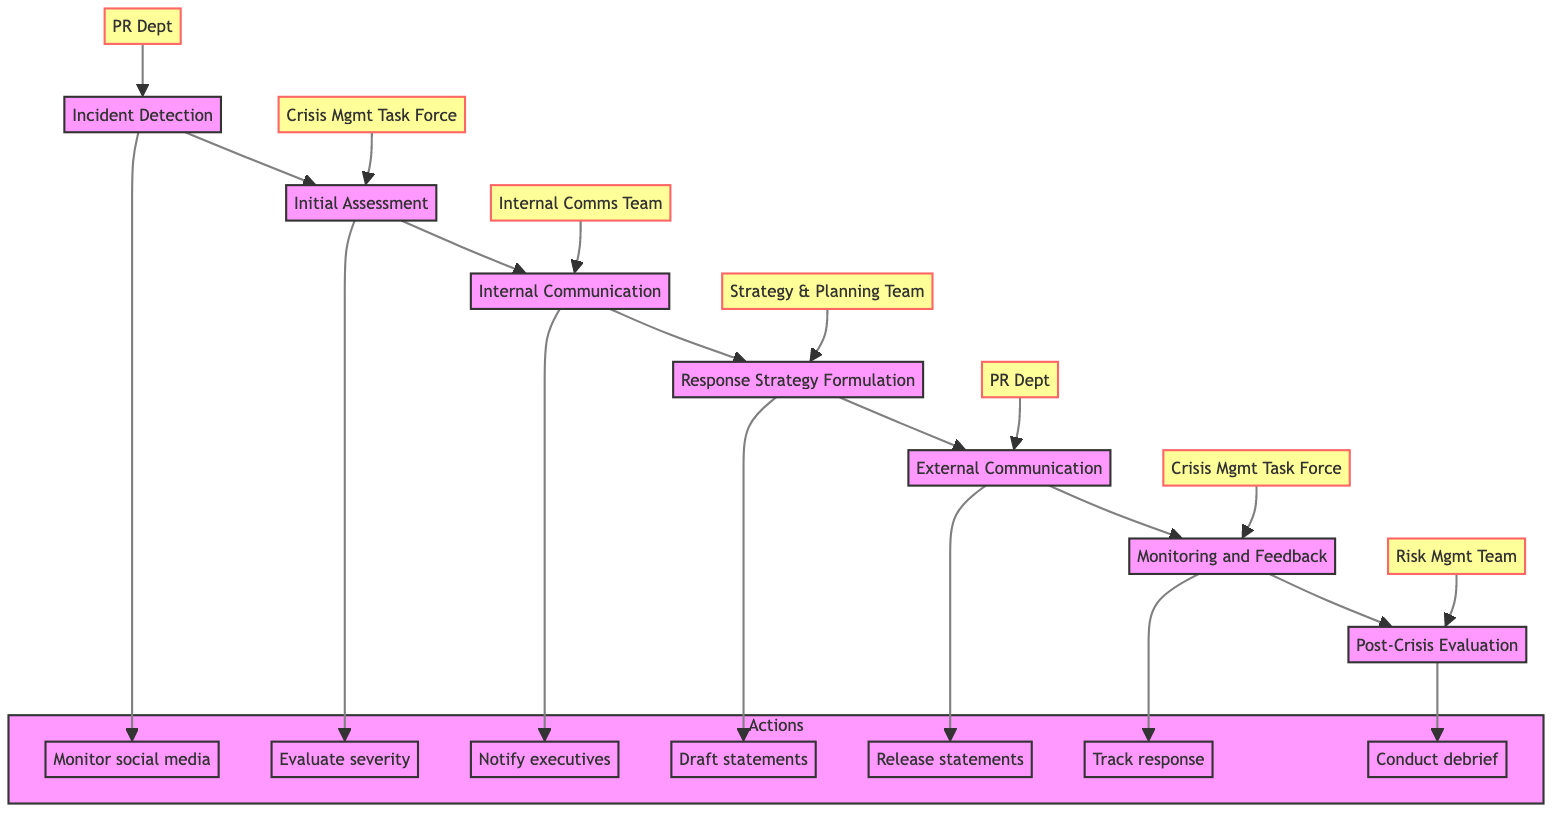What is the first stage in the diagram? The first stage in the diagram is labeled "Incident Detection," which is the starting point for the crisis management procedures.
Answer: Incident Detection How many total stages are there in the diagram? By counting the stages represented in the diagram, we find that there are seven distinct stages, from "Incident Detection" to "Post-Crisis Evaluation."
Answer: 7 What is the responsible team for the "External Communication" stage? The team responsible for the "External Communication" stage is the "Public Relations Department," as indicated in the diagram.
Answer: Public Relations Department Which action is associated with the "Response Strategy Formulation" stage? The action associated with the "Response Strategy Formulation" stage is to "Draft public statements in consultation with legal and PR teams," as shown in the diagram.
Answer: Draft public statements in consultation with legal and PR teams Which team is responsible for both "Monitoring and Feedback" and "Post-Crisis Evaluation"? The team responsible for both stages is the "Crisis Management Task Force," as it oversees the "Monitoring and Feedback" stage, and also plays a role in the "Post-Crisis Evaluation" stage.
Answer: Crisis Management Task Force What is the action that follows "Initial Assessment"? The action that directly follows "Initial Assessment" in the flowchart is "Internal Communication," indicating the flow of processes from one stage to the next.
Answer: Internal Communication What does the action in the "Monitoring and Feedback" phase involve? The action in the "Monitoring and Feedback" phase involves "Track the public and media response using analytics tools," which refers to the methods for evaluating the effectiveness of the response.
Answer: Track the public and media response using analytics tools In what sequence does the "External Communication" stage occur relative to "Initial Assessment"? The "External Communication" stage occurs after the "Response Strategy Formulation" stage, which follows the "Initial Assessment" stage, illustrating the sequence of events in handling a crisis.
Answer: After "Response Strategy Formulation" What is the last stage in the crisis management procedure? The last stage in the procedure is "Post-Crisis Evaluation," which signifies the conclusion of the crisis management process and includes debrief and review tasks.
Answer: Post-Crisis Evaluation 